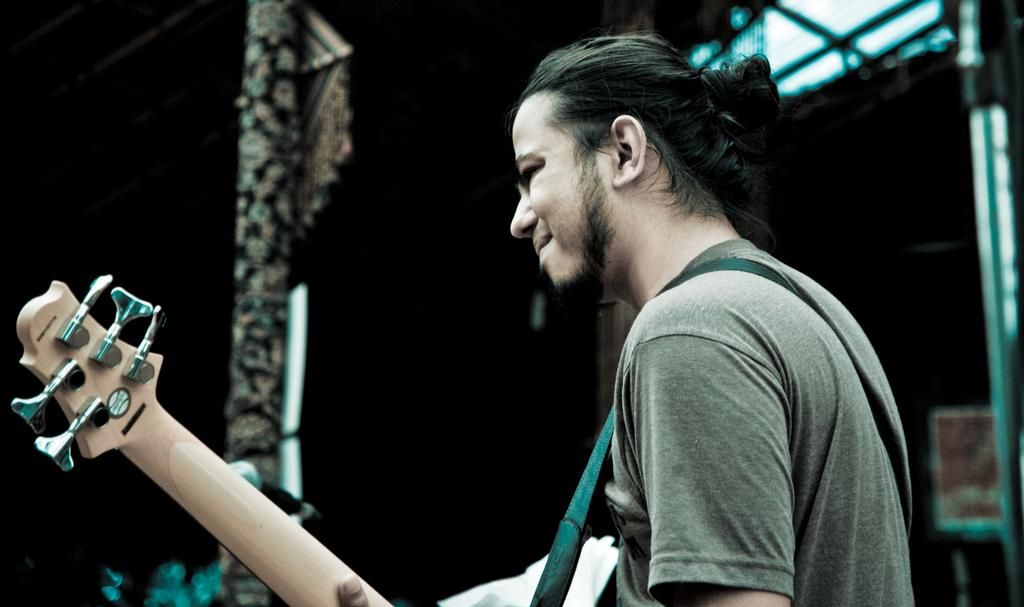What is present in the image? There is a person in the image. Can you describe what the person is wearing? The person is wearing a gray t-shirt. What is the person holding in their hand? The person is holding a guitar in their hand. What type of quiver is the person wearing in the image? There is no quiver present in the image; the person is wearing a gray t-shirt. What time of day is depicted in the image? The time of day is not specified in the image, so it cannot be determined. 